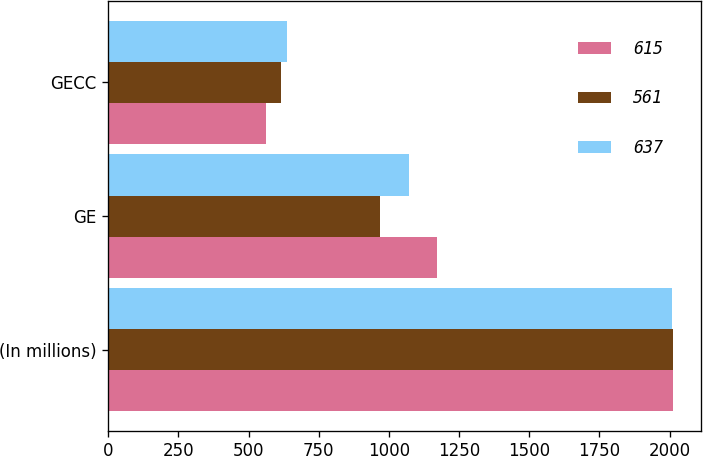Convert chart. <chart><loc_0><loc_0><loc_500><loc_500><stacked_bar_chart><ecel><fcel>(In millions)<fcel>GE<fcel>GECC<nl><fcel>615<fcel>2012<fcel>1170<fcel>561<nl><fcel>561<fcel>2011<fcel>968<fcel>615<nl><fcel>637<fcel>2010<fcel>1073<fcel>637<nl></chart> 